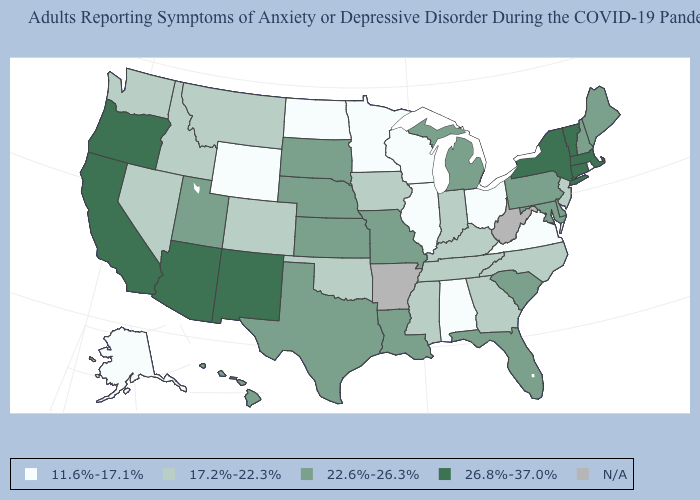Is the legend a continuous bar?
Write a very short answer. No. Which states have the lowest value in the MidWest?
Answer briefly. Illinois, Minnesota, North Dakota, Ohio, Wisconsin. How many symbols are there in the legend?
Answer briefly. 5. What is the value of Maryland?
Write a very short answer. 22.6%-26.3%. Name the states that have a value in the range 17.2%-22.3%?
Write a very short answer. Colorado, Georgia, Idaho, Indiana, Iowa, Kentucky, Mississippi, Montana, Nevada, New Jersey, North Carolina, Oklahoma, Tennessee, Washington. Does New Mexico have the highest value in the USA?
Answer briefly. Yes. How many symbols are there in the legend?
Be succinct. 5. Name the states that have a value in the range 22.6%-26.3%?
Write a very short answer. Delaware, Florida, Hawaii, Kansas, Louisiana, Maine, Maryland, Michigan, Missouri, Nebraska, New Hampshire, Pennsylvania, South Carolina, South Dakota, Texas, Utah. What is the value of Rhode Island?
Write a very short answer. 11.6%-17.1%. What is the lowest value in states that border Utah?
Keep it brief. 11.6%-17.1%. Name the states that have a value in the range 26.8%-37.0%?
Be succinct. Arizona, California, Connecticut, Massachusetts, New Mexico, New York, Oregon, Vermont. What is the value of New Jersey?
Answer briefly. 17.2%-22.3%. 